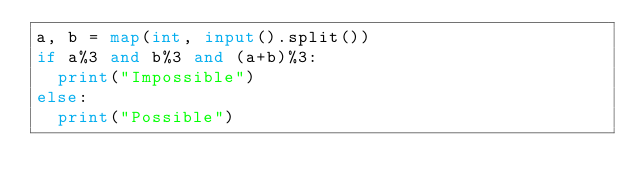Convert code to text. <code><loc_0><loc_0><loc_500><loc_500><_Python_>a, b = map(int, input().split())
if a%3 and b%3 and (a+b)%3:
  print("Impossible")
else:
  print("Possible")</code> 